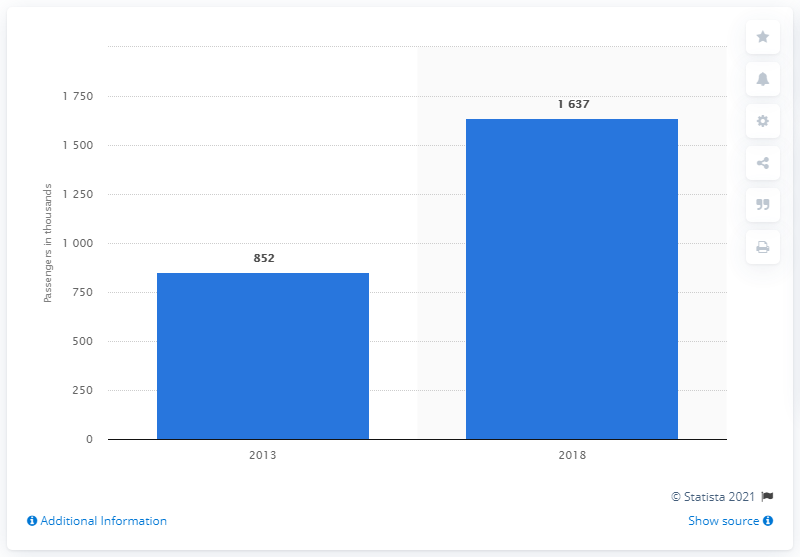Specify some key components in this picture. In 2018, the highest number of passengers were transported. The years considered in this context are those ranging from 5 to 9. 